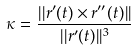Convert formula to latex. <formula><loc_0><loc_0><loc_500><loc_500>\kappa = \frac { | | r ^ { \prime } ( t ) \times r ^ { \prime \prime } ( t ) | | } { | | r ^ { \prime } ( t ) | | ^ { 3 } }</formula> 